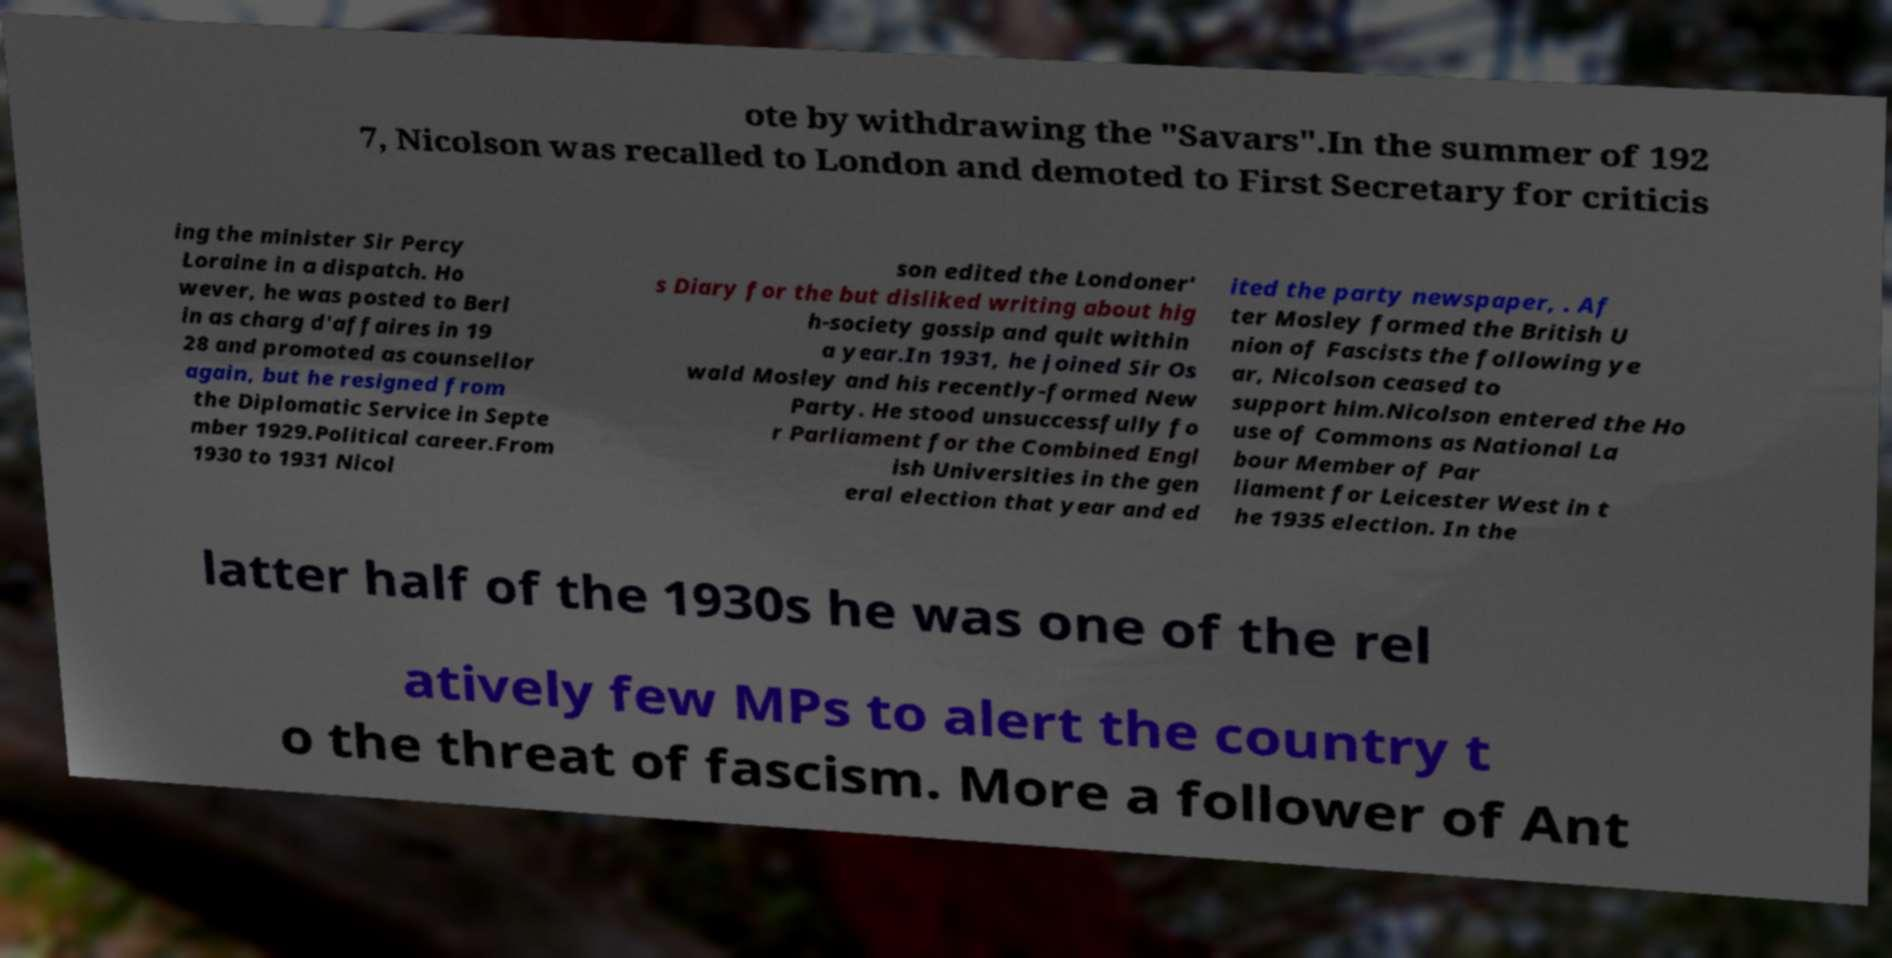Could you assist in decoding the text presented in this image and type it out clearly? ote by withdrawing the "Savars".In the summer of 192 7, Nicolson was recalled to London and demoted to First Secretary for criticis ing the minister Sir Percy Loraine in a dispatch. Ho wever, he was posted to Berl in as charg d'affaires in 19 28 and promoted as counsellor again, but he resigned from the Diplomatic Service in Septe mber 1929.Political career.From 1930 to 1931 Nicol son edited the Londoner' s Diary for the but disliked writing about hig h-society gossip and quit within a year.In 1931, he joined Sir Os wald Mosley and his recently-formed New Party. He stood unsuccessfully fo r Parliament for the Combined Engl ish Universities in the gen eral election that year and ed ited the party newspaper, . Af ter Mosley formed the British U nion of Fascists the following ye ar, Nicolson ceased to support him.Nicolson entered the Ho use of Commons as National La bour Member of Par liament for Leicester West in t he 1935 election. In the latter half of the 1930s he was one of the rel atively few MPs to alert the country t o the threat of fascism. More a follower of Ant 